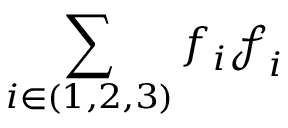Convert formula to latex. <formula><loc_0><loc_0><loc_500><loc_500>\sum _ { i \in ( 1 , 2 , 3 ) } f _ { i } \ m a t h s c r { f } _ { i }</formula> 